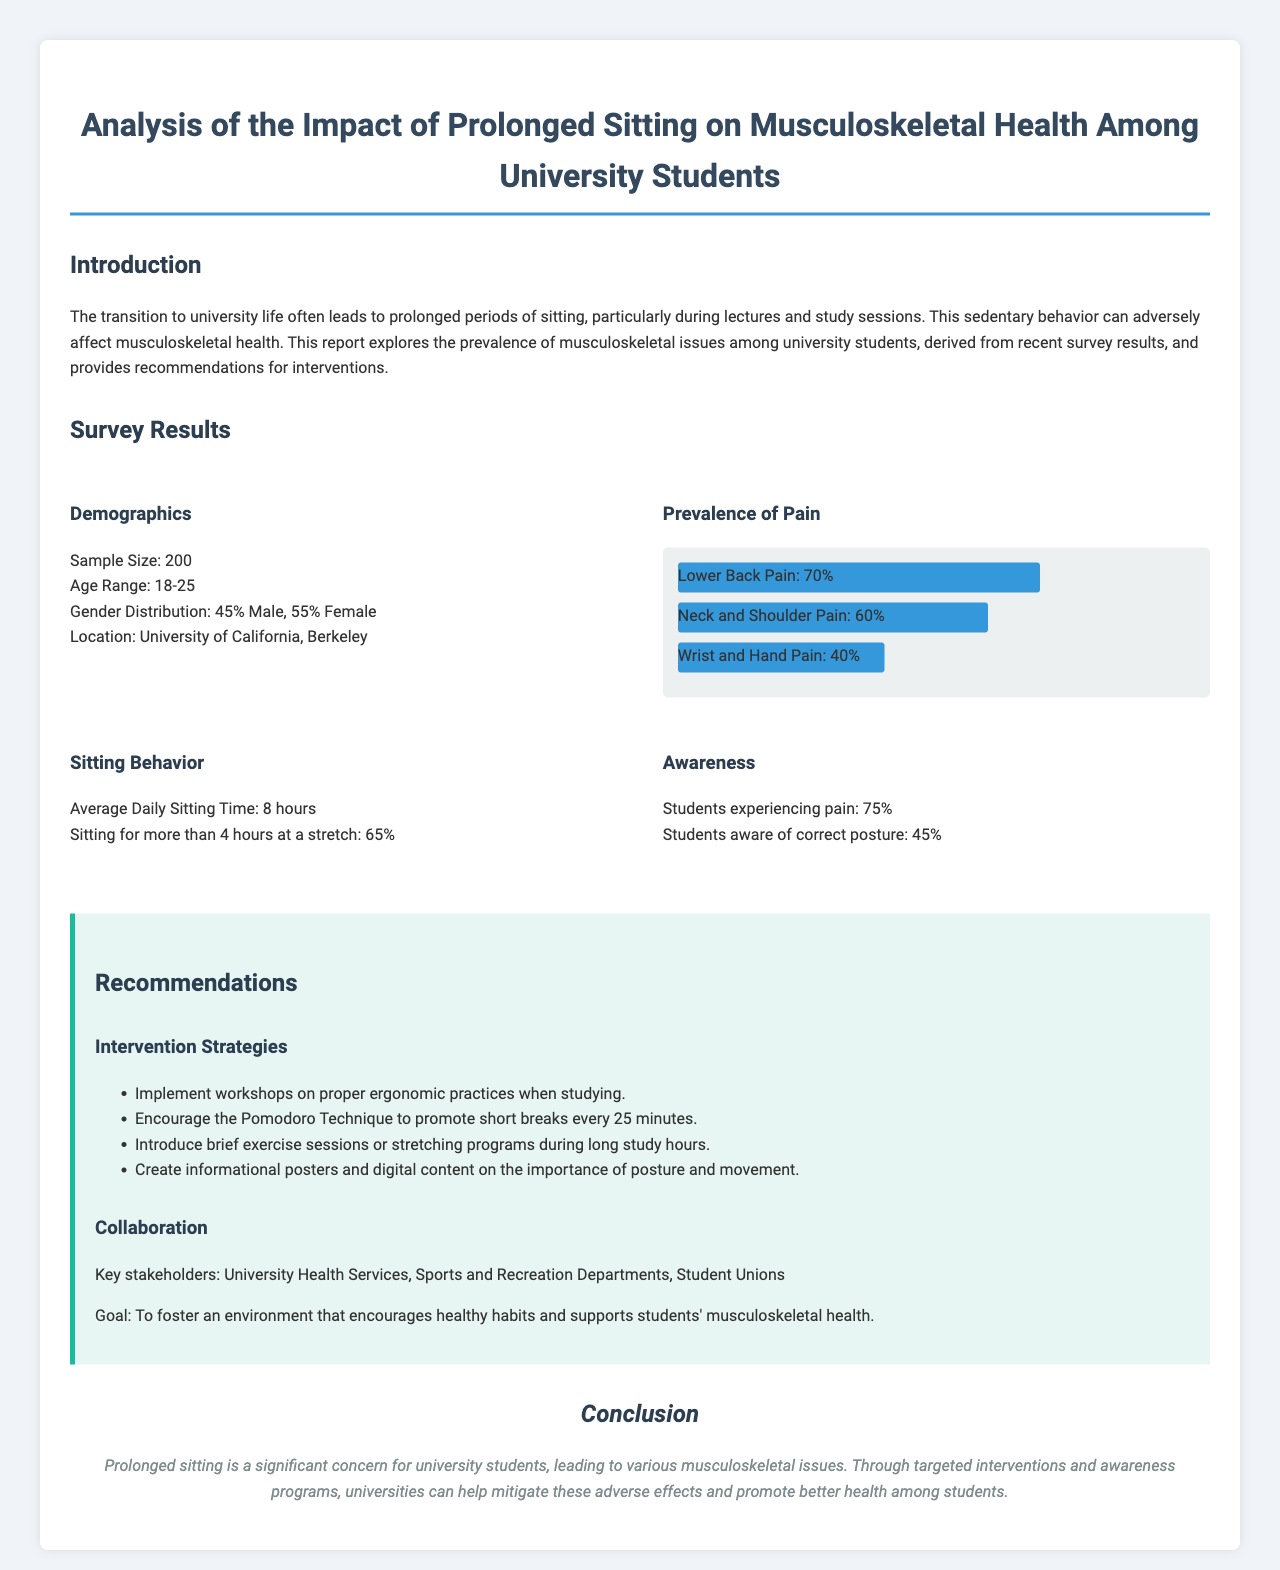What is the sample size of the survey? The sample size is mentioned in the survey results section of the document.
Answer: 200 What percentage of students report lower back pain? The percentage of students reporting lower back pain is shown in the survey results section.
Answer: 70% What is the average daily sitting time reported by the students? The average daily sitting time is stated in the sitting behavior survey result.
Answer: 8 hours What is the percentage of students aware of correct posture? The awareness of correct posture is presented in the awareness section of the survey results.
Answer: 45% What intervention strategy involves short breaks during study sessions? This strategy is mentioned in the recommendations section of the document.
Answer: Pomodoro Technique What is one key stakeholder mentioned for collaboration? The collaboration section lists stakeholders that are crucial for developing interventions.
Answer: University Health Services What percentage of students experience pain? The percentage of students experiencing pain is indicated in the awareness survey result.
Answer: 75% What is the recommended action to promote ergonomic practices? This recommendation is outlined in the intervention strategies within the recommendations section.
Answer: Workshops on proper ergonomic practices 